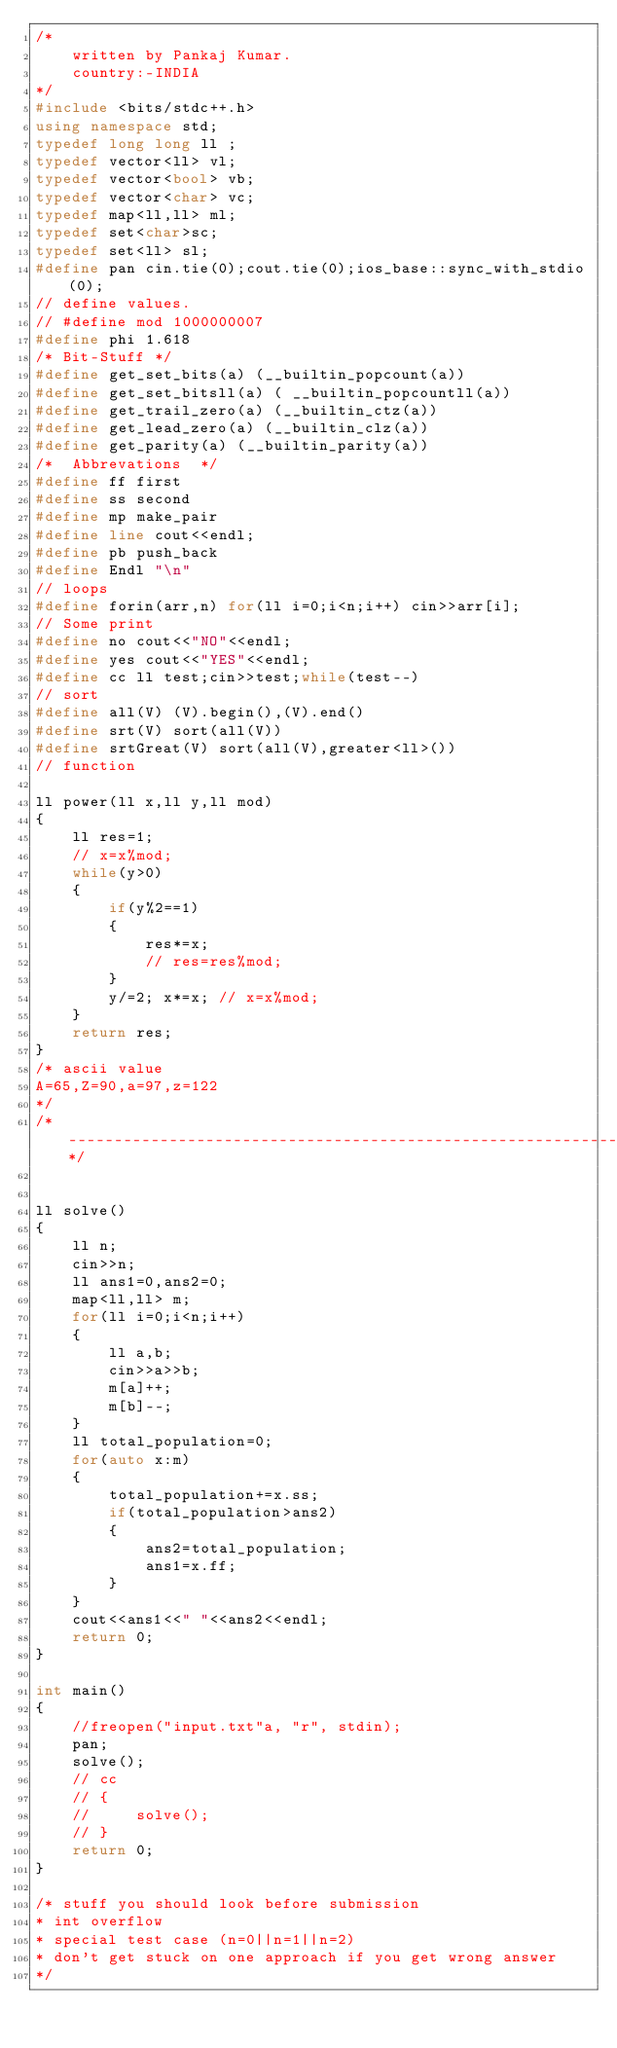Convert code to text. <code><loc_0><loc_0><loc_500><loc_500><_C++_>/*
    written by Pankaj Kumar.
    country:-INDIA
*/
#include <bits/stdc++.h>
using namespace std;
typedef long long ll ;
typedef vector<ll> vl;
typedef vector<bool> vb;
typedef vector<char> vc;
typedef map<ll,ll> ml;
typedef set<char>sc;
typedef set<ll> sl;
#define pan cin.tie(0);cout.tie(0);ios_base::sync_with_stdio(0);
// define values.
// #define mod 1000000007
#define phi 1.618
/* Bit-Stuff */
#define get_set_bits(a) (__builtin_popcount(a))
#define get_set_bitsll(a) ( __builtin_popcountll(a))
#define get_trail_zero(a) (__builtin_ctz(a))
#define get_lead_zero(a) (__builtin_clz(a))
#define get_parity(a) (__builtin_parity(a))
/*  Abbrevations  */
#define ff first
#define ss second
#define mp make_pair
#define line cout<<endl;
#define pb push_back
#define Endl "\n"
// loops
#define forin(arr,n) for(ll i=0;i<n;i++) cin>>arr[i];
// Some print
#define no cout<<"NO"<<endl;
#define yes cout<<"YES"<<endl;
#define cc ll test;cin>>test;while(test--)
// sort
#define all(V) (V).begin(),(V).end()
#define srt(V) sort(all(V))
#define srtGreat(V) sort(all(V),greater<ll>())
// function

ll power(ll x,ll y,ll mod)
{
    ll res=1;
    // x=x%mod;
    while(y>0)
    {
        if(y%2==1)
        {
            res*=x;
            // res=res%mod;
        }
        y/=2; x*=x; // x=x%mod;
    }
    return res;
}
/* ascii value 
A=65,Z=90,a=97,z=122
*/
/*  -----------------------------------------------------------------------------------*/


ll solve()
{
    ll n;
    cin>>n;
    ll ans1=0,ans2=0;
    map<ll,ll> m;
    for(ll i=0;i<n;i++)
    {
        ll a,b;
        cin>>a>>b;
        m[a]++;
        m[b]--;
    }
    ll total_population=0;
    for(auto x:m)
    {
        total_population+=x.ss;
        if(total_population>ans2)
        {
            ans2=total_population;
            ans1=x.ff;
        }
    }
    cout<<ans1<<" "<<ans2<<endl;
    return 0;
}

int main()
{
    //freopen("input.txt"a, "r", stdin);
    pan;
    solve();
    // cc
    // {
    //     solve();
    // }
    return 0;
}

/* stuff you should look before submission 
* int overflow
* special test case (n=0||n=1||n=2)
* don't get stuck on one approach if you get wrong answer
*/</code> 